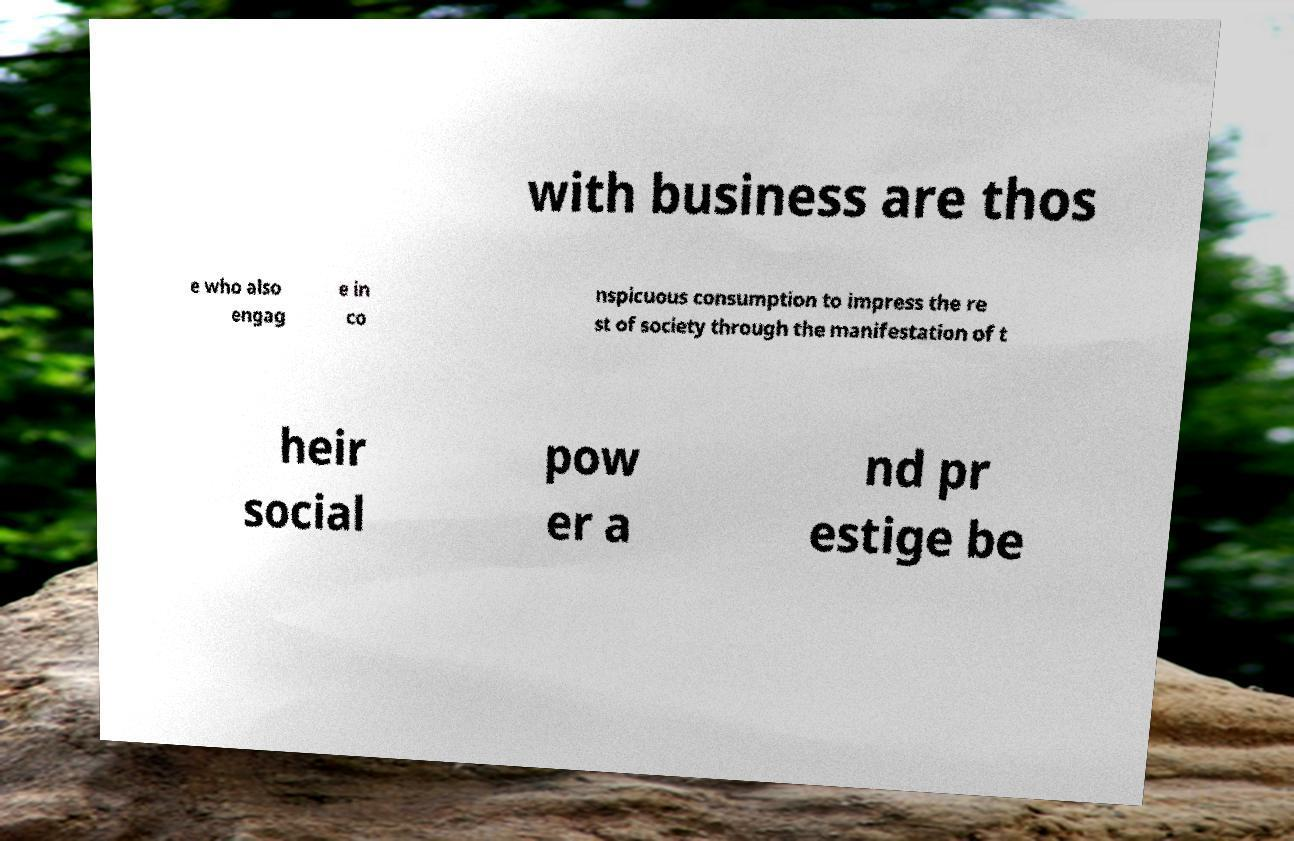Please identify and transcribe the text found in this image. with business are thos e who also engag e in co nspicuous consumption to impress the re st of society through the manifestation of t heir social pow er a nd pr estige be 